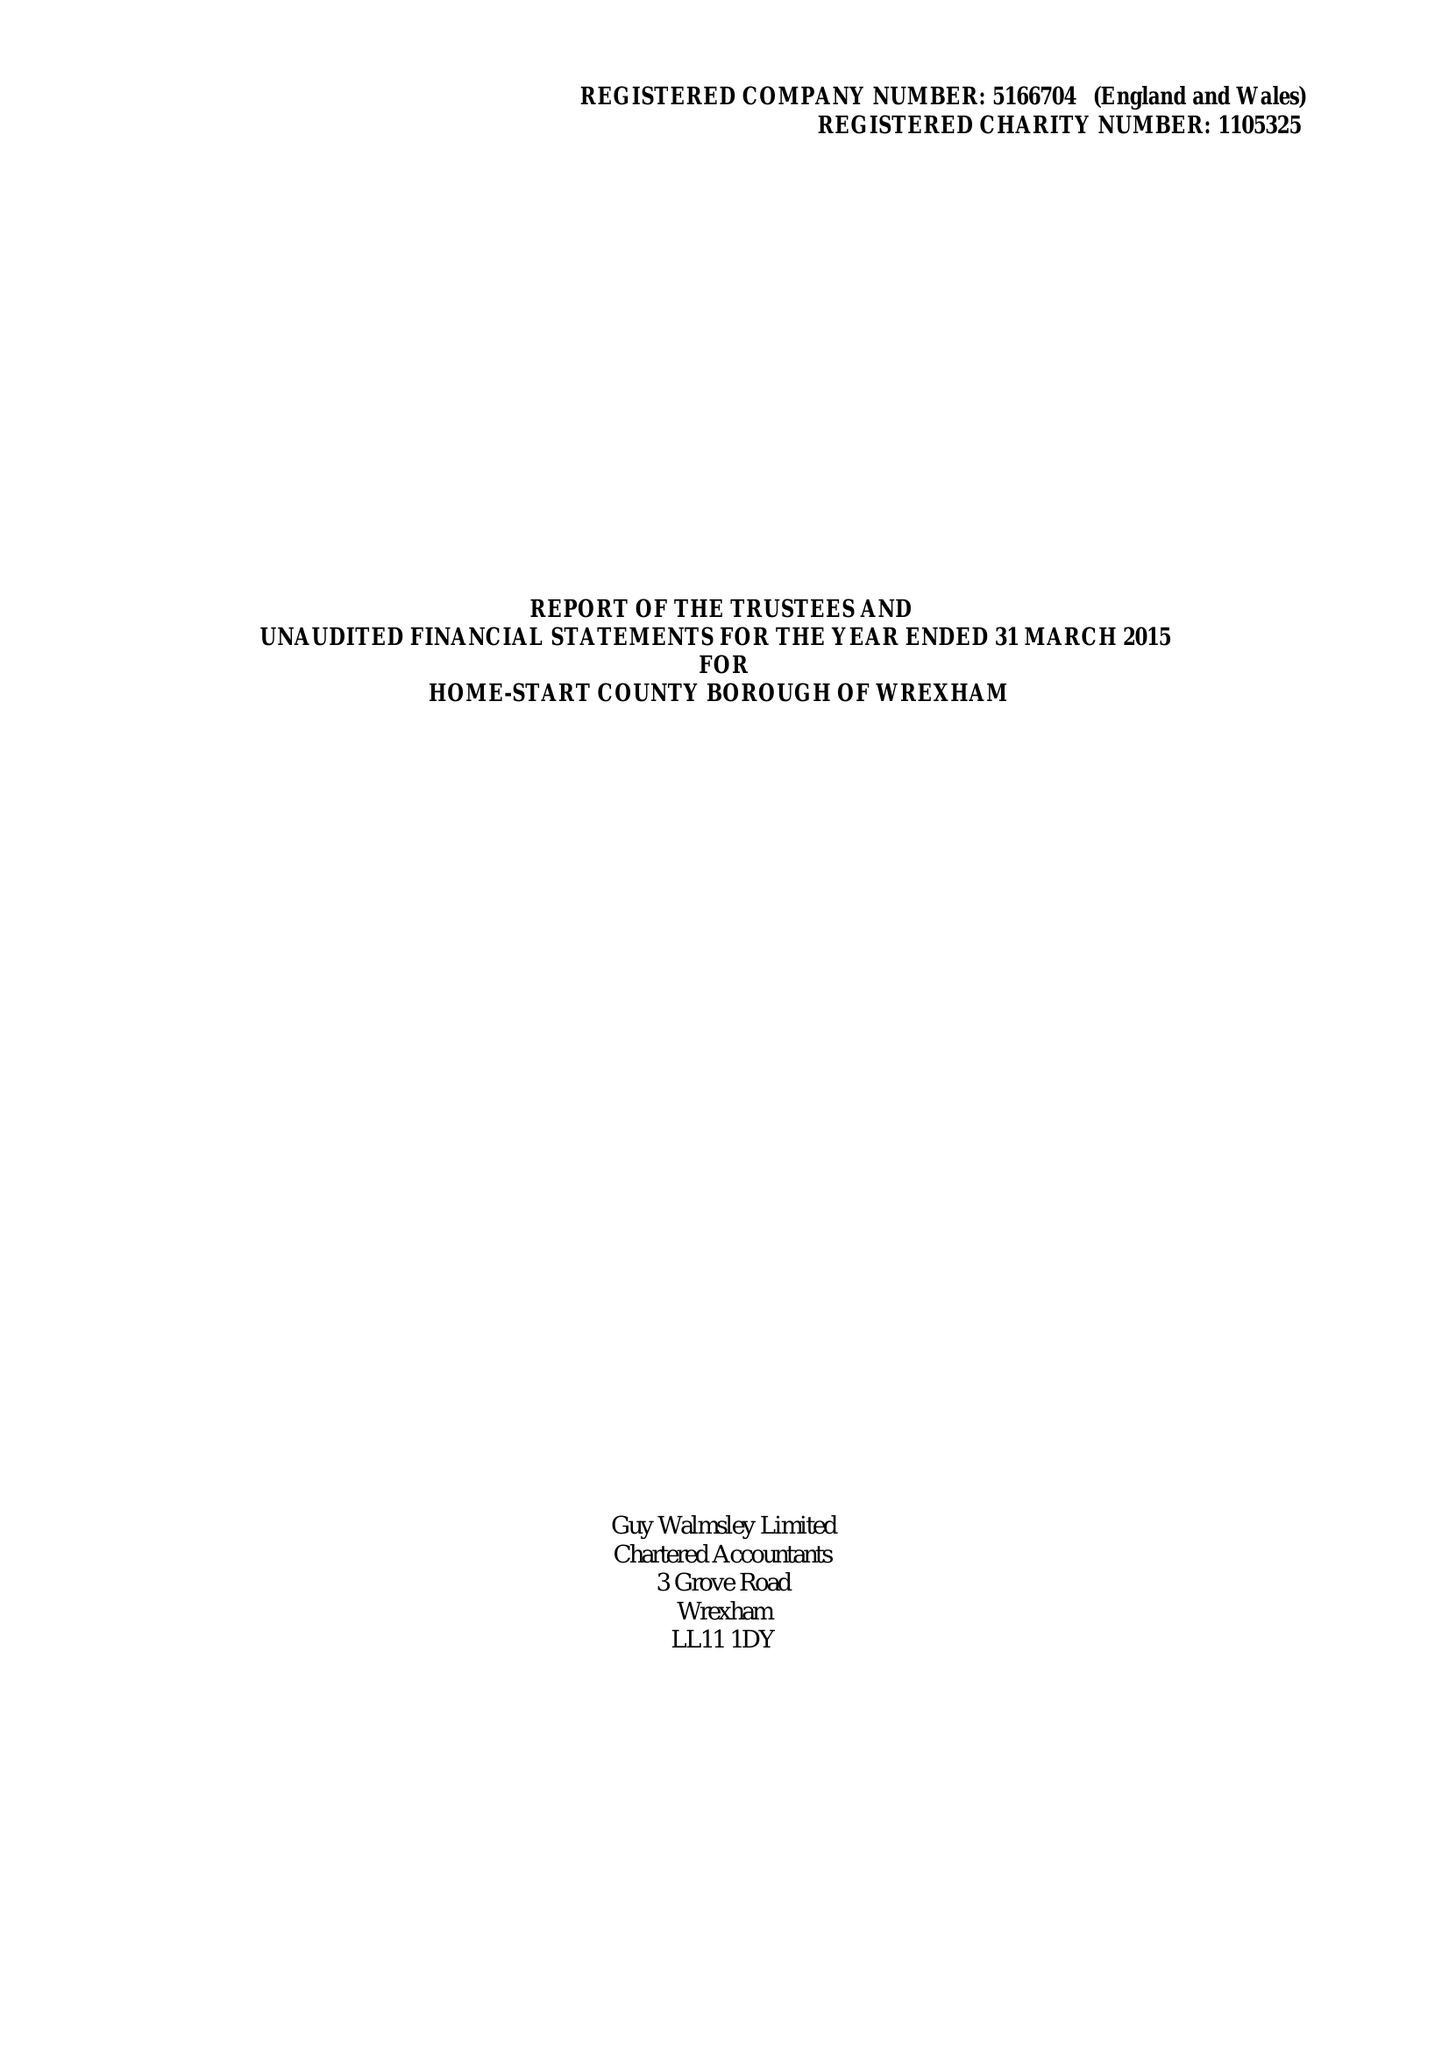What is the value for the charity_name?
Answer the question using a single word or phrase. Home-Start County Borough Of Wrexham 